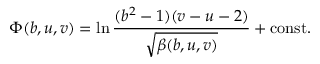Convert formula to latex. <formula><loc_0><loc_0><loc_500><loc_500>\Phi ( b , u , v ) = \ln \frac { ( b ^ { 2 } - 1 ) ( v - u - 2 ) } { \sqrt { \beta ( b , u , v ) } } + c o n s t .</formula> 